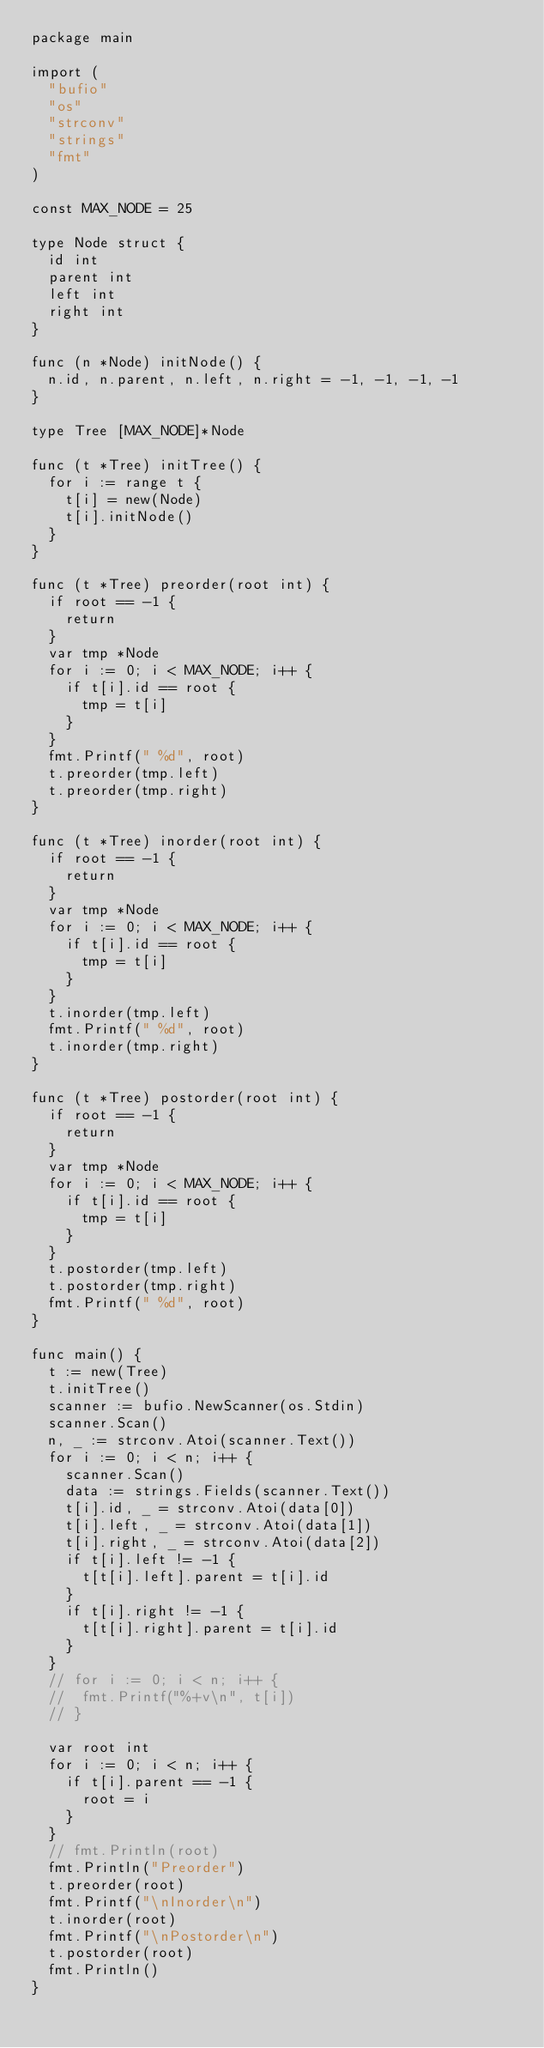Convert code to text. <code><loc_0><loc_0><loc_500><loc_500><_Go_>package main

import (
	"bufio"
	"os"
	"strconv"
	"strings"
	"fmt"
)

const MAX_NODE = 25

type Node struct {
	id int
	parent int
	left int
	right int
}

func (n *Node) initNode() {
	n.id, n.parent, n.left, n.right = -1, -1, -1, -1
}

type Tree [MAX_NODE]*Node

func (t *Tree) initTree() {
	for i := range t {
		t[i] = new(Node)
		t[i].initNode()
	}
}

func (t *Tree) preorder(root int) {
	if root == -1 {
		return
	}
	var tmp *Node
	for i := 0; i < MAX_NODE; i++ {
		if t[i].id == root {
			tmp = t[i]
		}
	}
	fmt.Printf(" %d", root)
	t.preorder(tmp.left)
	t.preorder(tmp.right)
}

func (t *Tree) inorder(root int) {
	if root == -1 {
		return
	}
	var tmp *Node
	for i := 0; i < MAX_NODE; i++ {
		if t[i].id == root {
			tmp = t[i]
		}
	}
	t.inorder(tmp.left)
	fmt.Printf(" %d", root)
	t.inorder(tmp.right)
}

func (t *Tree) postorder(root int) {
	if root == -1 {
		return
	}
	var tmp *Node
	for i := 0; i < MAX_NODE; i++ {
		if t[i].id == root {
			tmp = t[i]
		}
	}
	t.postorder(tmp.left)
	t.postorder(tmp.right)
	fmt.Printf(" %d", root)
}

func main() {
	t := new(Tree)
	t.initTree()
	scanner := bufio.NewScanner(os.Stdin)
	scanner.Scan()
	n, _ := strconv.Atoi(scanner.Text())
	for i := 0; i < n; i++ {
		scanner.Scan()
		data := strings.Fields(scanner.Text())
		t[i].id, _ = strconv.Atoi(data[0])
		t[i].left, _ = strconv.Atoi(data[1])
		t[i].right, _ = strconv.Atoi(data[2])
		if t[i].left != -1 {
			t[t[i].left].parent = t[i].id
		}
		if t[i].right != -1 {
			t[t[i].right].parent = t[i].id
		}
	}
	// for i := 0; i < n; i++ {
	// 	fmt.Printf("%+v\n", t[i])
	// }

	var root int
	for i := 0; i < n; i++ {
		if t[i].parent == -1 {
			root = i
		}
	}
	// fmt.Println(root)
	fmt.Println("Preorder")
	t.preorder(root)
	fmt.Printf("\nInorder\n")
	t.inorder(root)
	fmt.Printf("\nPostorder\n")
	t.postorder(root)
	fmt.Println()
}
</code> 